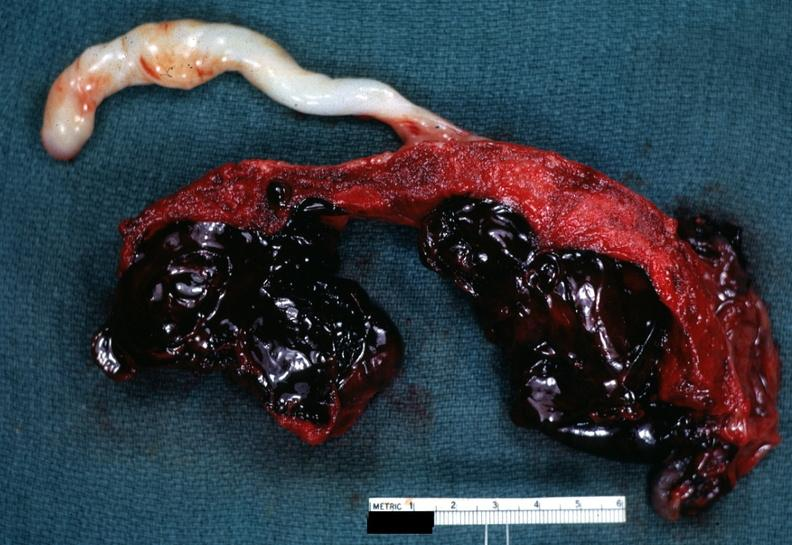s abruption present?
Answer the question using a single word or phrase. Yes 